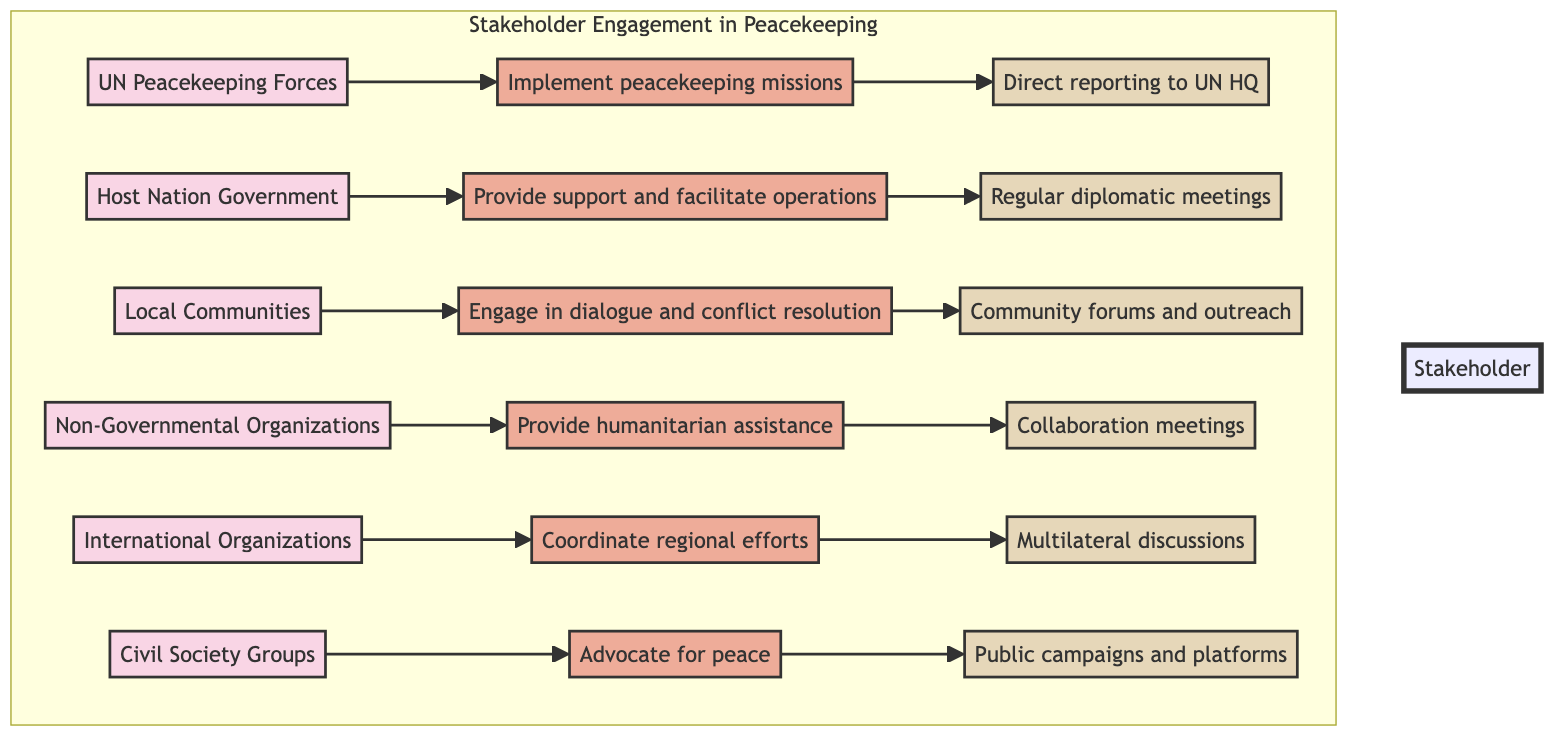What role do Non-Governmental Organizations play in peacekeeping? The diagram indicates that Non-Governmental Organizations provide humanitarian assistance and support local initiatives. This is directly linked to the role assigned to them in the flow chart.
Answer: Provide humanitarian assistance What communication channel is used by Local Communities? According to the flow chart, Local Communities engage through community forums and outreach programs as their primary communication channel. This is specifically highlighted in the diagram.
Answer: Community forums and outreach How many key actors are involved in Stakeholder Engagement in Peacekeeping? The diagram lists six key actors in total: UN Peacekeeping Forces, Host Nation Government, Local Communities, Non-Governmental Organizations, International Organizations, and Civil Society Groups. Counting each of these actors gives the total.
Answer: 6 What is the relationship between Host Nation Government and Regular diplomatic meetings? The flow chart shows that the Host Nation Government is connected to the role of providing support and facilitating operations, which is further linked to the communication channel of regular diplomatic meetings with UN representatives. This shows a direct flow from the actor to the role and then to the communication channel.
Answer: Support and facilitate operations Which actor coordinates regional efforts and what is the associated communication channel? International Organizations are identified in the diagram as the actor that coordinates regional efforts. Their associated communication channel is multilateral discussions and strategic partnerships. This direct connection is reflected in the flow structure of the chart.
Answer: International Organizations; Multilateral discussions What role does Civil Society Groups have in peacekeeping? The diagram specifies that Civil Society Groups advocate for peace and represent community interests, providing a clear understanding of their role within the peacekeeping framework.
Answer: Advocate for peace What is the primary function of UN Peacekeeping Forces as shown in the diagram? The flow chart indicates that the primary function of UN Peacekeeping Forces is to implement peacekeeping missions on the ground. This can be seen directly from the relationship outlined in the diagram.
Answer: Implement peacekeeping missions What type of organizations are classified as International Organizations in the diagram? The diagram cites specific examples of International Organizations such as the African Union and the EU. By identifying these entities, we can classify them under the broader category of International Organizations involved in peacekeeping.
Answer: African Union, EU How do Non-Governmental Organizations communicate with peacekeepers? As per the flow chart, Non-Governmental Organizations communicate with peacekeepers through collaboration meetings and joint programs. This shows their interaction method with the peacekeeping forces, emphasizing partnership.
Answer: Collaboration meetings and joint programs 